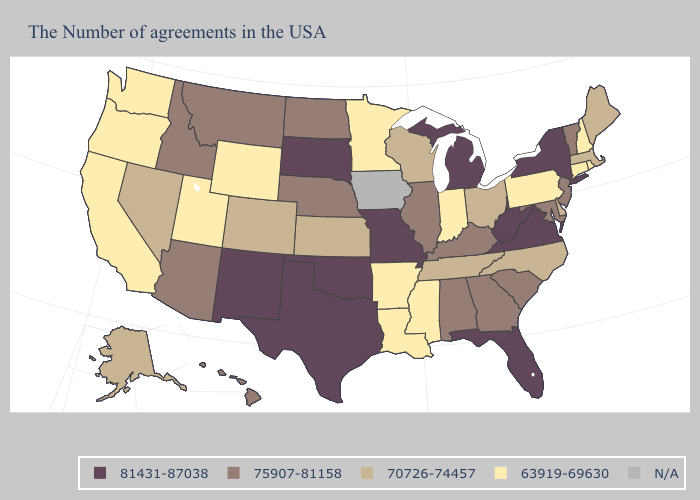Among the states that border Tennessee , does Virginia have the highest value?
Quick response, please. Yes. What is the lowest value in the USA?
Give a very brief answer. 63919-69630. Among the states that border Louisiana , which have the highest value?
Concise answer only. Texas. Name the states that have a value in the range N/A?
Quick response, please. Iowa. What is the value of Michigan?
Write a very short answer. 81431-87038. What is the value of Idaho?
Concise answer only. 75907-81158. Which states have the highest value in the USA?
Give a very brief answer. New York, Virginia, West Virginia, Florida, Michigan, Missouri, Oklahoma, Texas, South Dakota, New Mexico. Name the states that have a value in the range 63919-69630?
Answer briefly. Rhode Island, New Hampshire, Connecticut, Pennsylvania, Indiana, Mississippi, Louisiana, Arkansas, Minnesota, Wyoming, Utah, California, Washington, Oregon. What is the highest value in the Northeast ?
Write a very short answer. 81431-87038. Among the states that border West Virginia , does Kentucky have the lowest value?
Answer briefly. No. Does South Dakota have the lowest value in the USA?
Keep it brief. No. What is the value of New Jersey?
Answer briefly. 75907-81158. Which states have the lowest value in the Northeast?
Short answer required. Rhode Island, New Hampshire, Connecticut, Pennsylvania. Name the states that have a value in the range 70726-74457?
Concise answer only. Maine, Massachusetts, Delaware, North Carolina, Ohio, Tennessee, Wisconsin, Kansas, Colorado, Nevada, Alaska. 